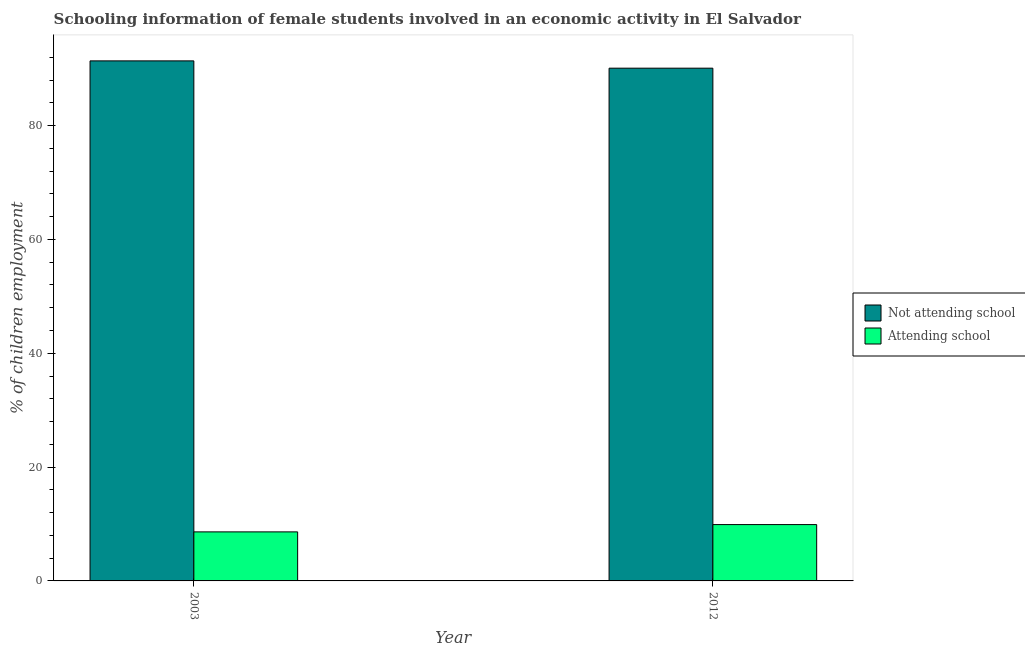How many groups of bars are there?
Provide a short and direct response. 2. Are the number of bars per tick equal to the number of legend labels?
Ensure brevity in your answer.  Yes. Are the number of bars on each tick of the X-axis equal?
Offer a very short reply. Yes. How many bars are there on the 2nd tick from the left?
Ensure brevity in your answer.  2. What is the label of the 2nd group of bars from the left?
Give a very brief answer. 2012. What is the percentage of employed females who are attending school in 2003?
Offer a very short reply. 8.62. Across all years, what is the minimum percentage of employed females who are attending school?
Provide a succinct answer. 8.62. What is the total percentage of employed females who are attending school in the graph?
Provide a succinct answer. 18.52. What is the difference between the percentage of employed females who are attending school in 2003 and that in 2012?
Your answer should be compact. -1.28. What is the difference between the percentage of employed females who are not attending school in 2012 and the percentage of employed females who are attending school in 2003?
Your answer should be compact. -1.28. What is the average percentage of employed females who are attending school per year?
Provide a succinct answer. 9.26. In how many years, is the percentage of employed females who are attending school greater than 4 %?
Provide a short and direct response. 2. What is the ratio of the percentage of employed females who are not attending school in 2003 to that in 2012?
Give a very brief answer. 1.01. Is the percentage of employed females who are attending school in 2003 less than that in 2012?
Offer a terse response. Yes. What does the 2nd bar from the left in 2012 represents?
Give a very brief answer. Attending school. What does the 2nd bar from the right in 2003 represents?
Make the answer very short. Not attending school. How many years are there in the graph?
Ensure brevity in your answer.  2. What is the difference between two consecutive major ticks on the Y-axis?
Ensure brevity in your answer.  20. Does the graph contain grids?
Your answer should be very brief. No. How many legend labels are there?
Make the answer very short. 2. How are the legend labels stacked?
Provide a short and direct response. Vertical. What is the title of the graph?
Offer a very short reply. Schooling information of female students involved in an economic activity in El Salvador. What is the label or title of the Y-axis?
Offer a very short reply. % of children employment. What is the % of children employment in Not attending school in 2003?
Give a very brief answer. 91.38. What is the % of children employment of Attending school in 2003?
Your answer should be compact. 8.62. What is the % of children employment in Not attending school in 2012?
Give a very brief answer. 90.1. What is the % of children employment in Attending school in 2012?
Your answer should be compact. 9.9. Across all years, what is the maximum % of children employment of Not attending school?
Make the answer very short. 91.38. Across all years, what is the maximum % of children employment in Attending school?
Your answer should be very brief. 9.9. Across all years, what is the minimum % of children employment in Not attending school?
Offer a very short reply. 90.1. Across all years, what is the minimum % of children employment in Attending school?
Your answer should be very brief. 8.62. What is the total % of children employment of Not attending school in the graph?
Provide a short and direct response. 181.48. What is the total % of children employment of Attending school in the graph?
Make the answer very short. 18.52. What is the difference between the % of children employment of Not attending school in 2003 and that in 2012?
Provide a short and direct response. 1.28. What is the difference between the % of children employment of Attending school in 2003 and that in 2012?
Offer a terse response. -1.28. What is the difference between the % of children employment in Not attending school in 2003 and the % of children employment in Attending school in 2012?
Offer a very short reply. 81.48. What is the average % of children employment of Not attending school per year?
Keep it short and to the point. 90.74. What is the average % of children employment in Attending school per year?
Your response must be concise. 9.26. In the year 2003, what is the difference between the % of children employment of Not attending school and % of children employment of Attending school?
Provide a short and direct response. 82.77. In the year 2012, what is the difference between the % of children employment in Not attending school and % of children employment in Attending school?
Ensure brevity in your answer.  80.2. What is the ratio of the % of children employment in Not attending school in 2003 to that in 2012?
Give a very brief answer. 1.01. What is the ratio of the % of children employment of Attending school in 2003 to that in 2012?
Offer a very short reply. 0.87. What is the difference between the highest and the second highest % of children employment of Not attending school?
Your response must be concise. 1.28. What is the difference between the highest and the second highest % of children employment in Attending school?
Make the answer very short. 1.28. What is the difference between the highest and the lowest % of children employment in Not attending school?
Provide a short and direct response. 1.28. What is the difference between the highest and the lowest % of children employment of Attending school?
Offer a terse response. 1.28. 